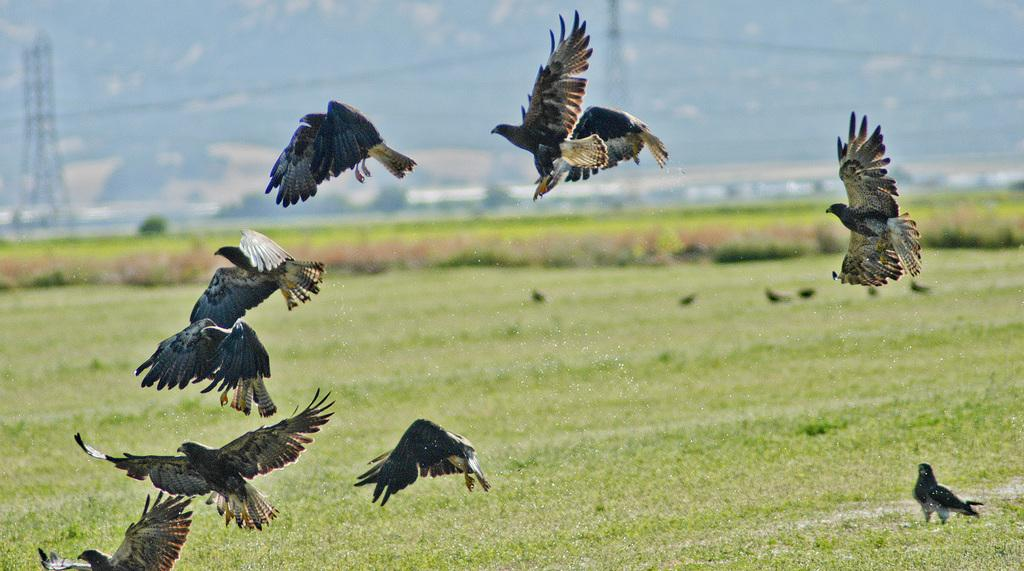What is happening in the sky in the image? There are birds flying in the air. What can be seen on the ground in the image? The ground is covered in greenery. What is visible in the background of the image? There are poles in the background. Can you tell me how many kittens are playing with a yam in the image? There is no kitten or yam present in the image; it features birds flying in the air and greenery on the ground. 